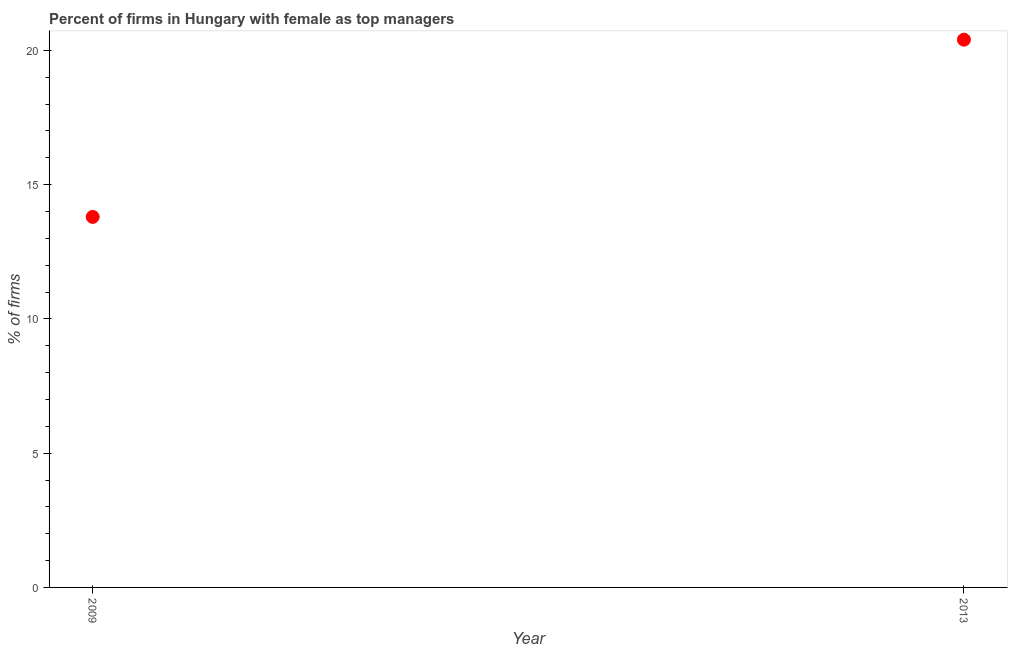What is the percentage of firms with female as top manager in 2013?
Your answer should be compact. 20.4. Across all years, what is the maximum percentage of firms with female as top manager?
Your answer should be very brief. 20.4. In which year was the percentage of firms with female as top manager maximum?
Your answer should be very brief. 2013. What is the sum of the percentage of firms with female as top manager?
Ensure brevity in your answer.  34.2. What is the difference between the percentage of firms with female as top manager in 2009 and 2013?
Provide a short and direct response. -6.6. What is the median percentage of firms with female as top manager?
Your answer should be compact. 17.1. In how many years, is the percentage of firms with female as top manager greater than 10 %?
Your answer should be very brief. 2. Do a majority of the years between 2009 and 2013 (inclusive) have percentage of firms with female as top manager greater than 11 %?
Ensure brevity in your answer.  Yes. What is the ratio of the percentage of firms with female as top manager in 2009 to that in 2013?
Offer a very short reply. 0.68. Is the percentage of firms with female as top manager in 2009 less than that in 2013?
Provide a succinct answer. Yes. In how many years, is the percentage of firms with female as top manager greater than the average percentage of firms with female as top manager taken over all years?
Your response must be concise. 1. How many dotlines are there?
Your answer should be compact. 1. What is the difference between two consecutive major ticks on the Y-axis?
Make the answer very short. 5. Does the graph contain any zero values?
Your response must be concise. No. Does the graph contain grids?
Offer a terse response. No. What is the title of the graph?
Keep it short and to the point. Percent of firms in Hungary with female as top managers. What is the label or title of the Y-axis?
Ensure brevity in your answer.  % of firms. What is the % of firms in 2013?
Offer a terse response. 20.4. What is the ratio of the % of firms in 2009 to that in 2013?
Offer a very short reply. 0.68. 